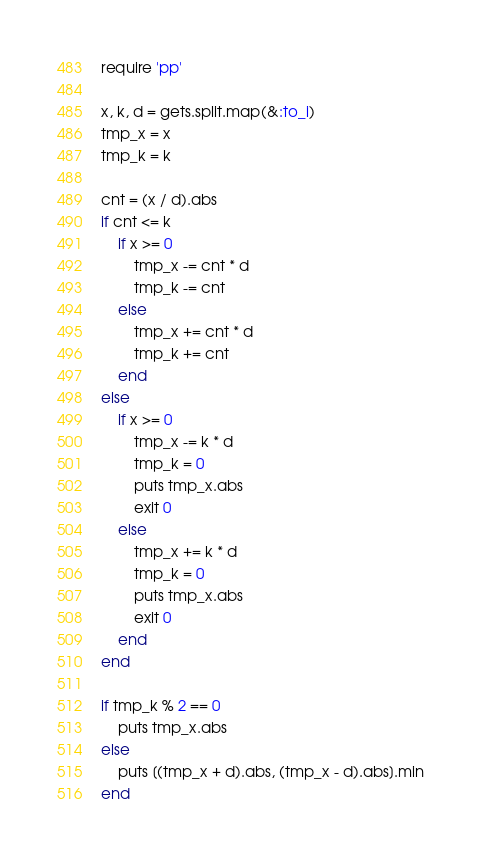Convert code to text. <code><loc_0><loc_0><loc_500><loc_500><_Ruby_>require 'pp'

x, k, d = gets.split.map(&:to_i)
tmp_x = x
tmp_k = k

cnt = (x / d).abs 
if cnt <= k
    if x >= 0
        tmp_x -= cnt * d
        tmp_k -= cnt
    else
        tmp_x += cnt * d
        tmp_k += cnt 
    end
else
    if x >= 0
        tmp_x -= k * d
        tmp_k = 0
        puts tmp_x.abs
        exit 0
    else
        tmp_x += k * d
        tmp_k = 0
        puts tmp_x.abs
        exit 0 
    end
end

if tmp_k % 2 == 0
    puts tmp_x.abs
else
    puts [(tmp_x + d).abs, (tmp_x - d).abs].min
end
</code> 